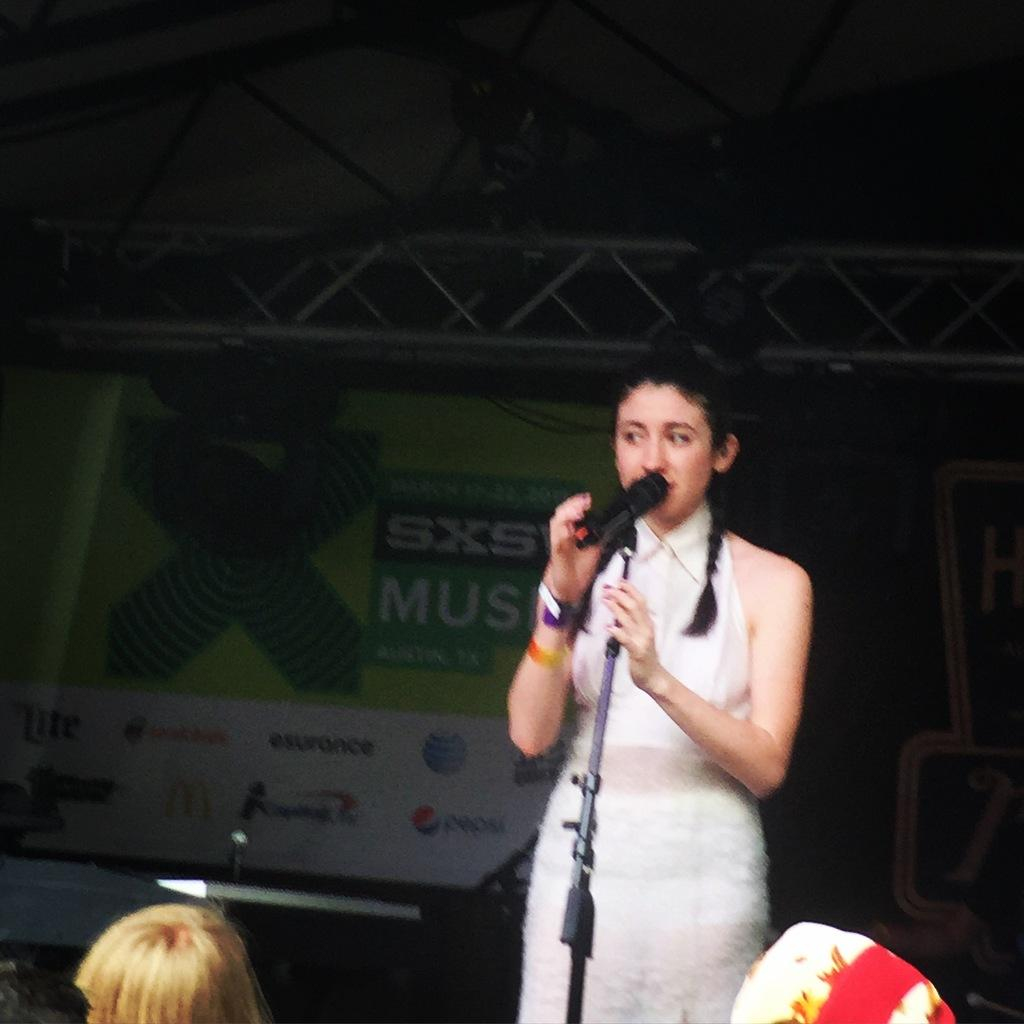Who is the main subject in the image? There is a girl in the image. Where is the girl located in the image? The girl is standing on a stage. What is the girl doing on the stage? The girl is speaking into a microphone. Who is the girl addressing in the image? There are people in front of the girl. Can you see any snails crawling on the stage in the image? No, there are no snails present in the image. What type of star is shining above the girl in the image? There is no star visible in the image; it is set on a stage with a background. 